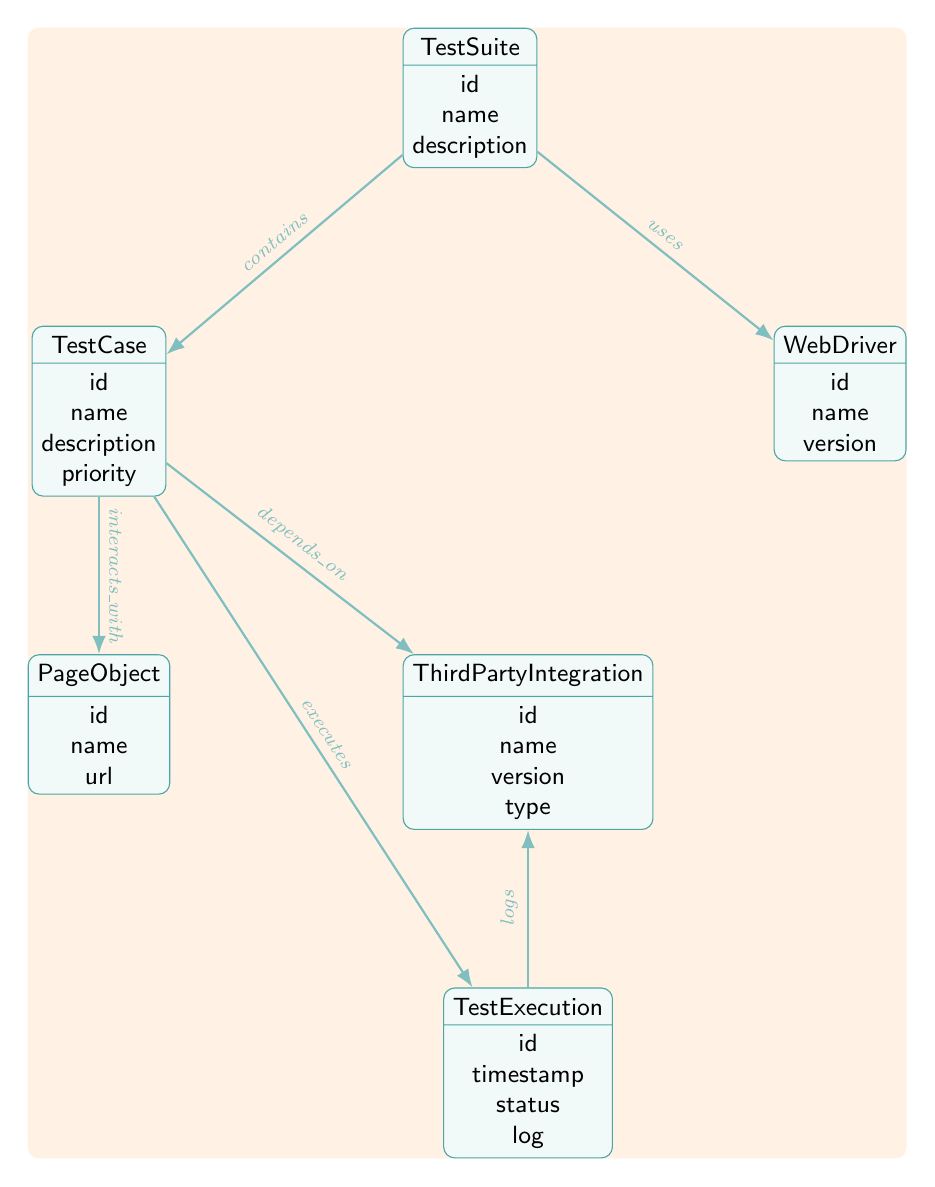What is the name of the entity that contains Test Cases? The relationship shown in the diagram indicates that the Test Suite is the entity that contains Test Cases.
Answer: TestSuite How many attributes does the Third Party Integration entity have? The Third Party Integration entity has four attributes: id, name, version, and type.
Answer: 4 What is the type of relationship between TestCase and PageObject? The diagram shows that the relationship between TestCase and PageObject is labeled as "interacts_with," indicating their interactive connection.
Answer: interacts_with Which entity does TestExecution log information for? The diagram indicates that TestExecution logs information related to the Third Party Integration entity through the "logs" relationship.
Answer: ThirdPartyIntegration What is the status attribute in the TestExecution entity used for? The status attribute within the TestExecution entity is used to indicate the current state of the test execution at the time it was recorded.
Answer: status How many entities are there in the diagram? By counting each unique entity in the diagram, we find that there are six entities represented.
Answer: 6 Which entity directly depends on Third Party Integration? The diagram shows a direct relationship indicating that the TestCase entity depends on the Third Party Integration entity, represented by the "depends_on" relationship.
Answer: TestCase What relationship type connects TestSuite with WebDriver? The relationship type connecting TestSuite with WebDriver is labeled as "uses," which indicates that the Test Suite utilizes the WebDriver in its operations.
Answer: uses What attribute does the TestCase entity include that indicates its level of importance? The TestCase entity includes the attribute "priority," which indicates the level of importance assigned to each test case.
Answer: priority Which entity is executed by TestCase? The diagram shows that TestCase executes the TestExecution entity through the "executes" relationship, indicating the execution process.
Answer: TestExecution 